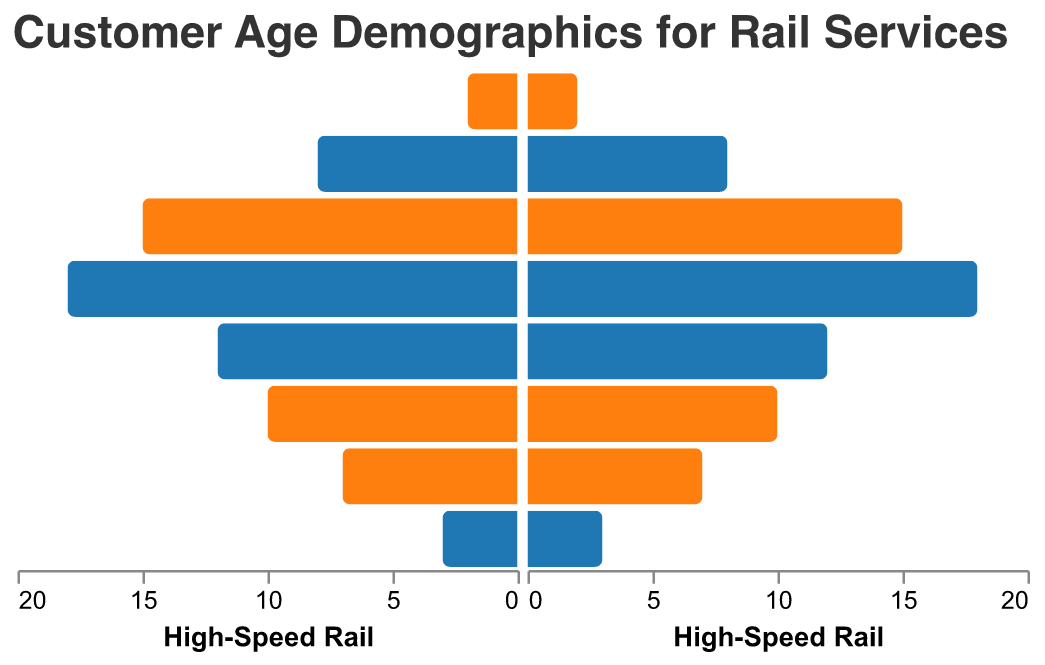What is the title of the figure? The title of the figure can be found at the top of the chart, which reads "Customer Age Demographics for Rail Services".
Answer: Customer Age Demographics for Rail Services Which age group has the highest number of high-speed rail customers? The highest bar under the "High-Speed Rail" category on the positive side indicates the age group "35-44" with a value of 17.
Answer: 35-44 What is the difference between the number of high-speed rail customers in the age groups 25-34 and 55-64? The bar for the age group 25-34 shows a value of 14, and the bar for the 55-64 age group shows a value of 9. The difference is 14 - 9 = 5.
Answer: 5 Which rail service has the lowest number of customers in the age group 75+? By comparing the lengths of the bars for all rail services in the 75+ age group, the shortest bar appears in "Regional Rail" with a value of -2 on the negative side.
Answer: Regional Rail In the age group 15-24, do high-speed rail customers outnumber commuter rail customers? Compare the bar lengths for the age group 15-24: High-Speed (7) vs. Commuter (6). Since 7 is greater than 6, high-speed rail customers outnumber those of commuter rail in this age group.
Answer: Yes How many more high-speed rail customers are there compared to regional rail customers in the age group 65-74? The values for 65-74 age group are 6 (High-Speed) and 4 (Regional). The difference is calculated as 6 - 4 = 2.
Answer: 2 What age group has the smallest customer base for freight rail? The smallest bar for "Freight Rail" on the negative side is for the "15-24" age group with a value of -1.
Answer: 15-24 Which service has the highest difference in customer numbers between the age groups 35-44 and 45-54? The data shows High-Speed Rail has 17 for 35-44 and 11 for 45-54. The difference is highest here being 17 - 11 = 6 compared to equivalent age group differences in other rail services.
Answer: High-Speed Rail Which age group shows the largest decline in high-speed rail customers as age increases? The decline can be calculated between consecutive age groups; the largest difference occurs between 35-44 (17) and 45-54 (11), a decline of 17 - 11 = 6.
Answer: 35-44 to 45-54 